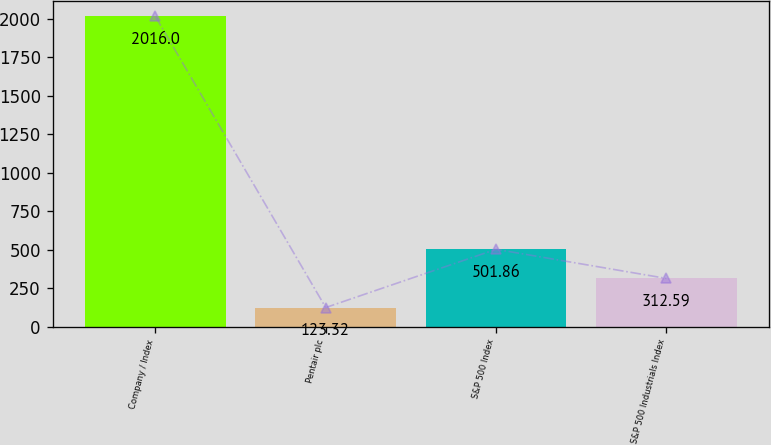Convert chart to OTSL. <chart><loc_0><loc_0><loc_500><loc_500><bar_chart><fcel>Company / Index<fcel>Pentair plc<fcel>S&P 500 Index<fcel>S&P 500 Industrials Index<nl><fcel>2016<fcel>123.32<fcel>501.86<fcel>312.59<nl></chart> 